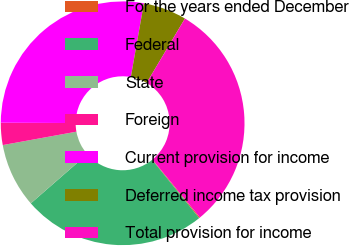Convert chart. <chart><loc_0><loc_0><loc_500><loc_500><pie_chart><fcel>For the years ended December<fcel>Federal<fcel>State<fcel>Foreign<fcel>Current provision for income<fcel>Deferred income tax provision<fcel>Total provision for income<nl><fcel>0.13%<fcel>24.39%<fcel>8.55%<fcel>2.94%<fcel>27.71%<fcel>5.75%<fcel>30.52%<nl></chart> 